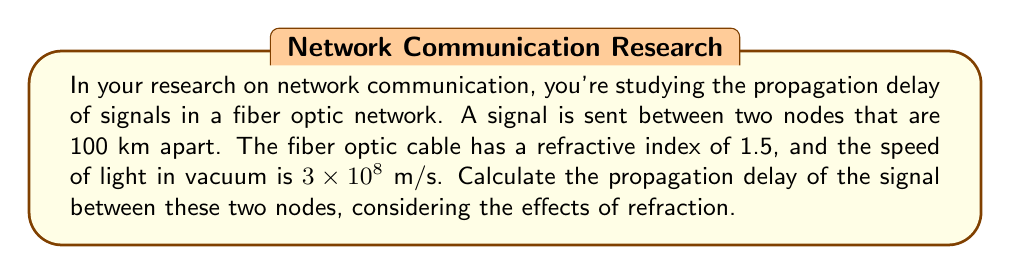Show me your answer to this math problem. To solve this problem, we need to follow these steps:

1. Understand the given information:
   - Distance between nodes: $d = 100$ km = $1 \times 10^5$ m
   - Refractive index of the fiber optic cable: $n = 1.5$
   - Speed of light in vacuum: $c = 3 \times 10^8$ m/s

2. Calculate the speed of light in the fiber optic cable:
   The speed of light in a medium is given by the formula:
   $$v = \frac{c}{n}$$
   Where $v$ is the speed of light in the medium, $c$ is the speed of light in vacuum, and $n$ is the refractive index.

   Substituting the values:
   $$v = \frac{3 \times 10^8}{1.5} = 2 \times 10^8 \text{ m/s}$$

3. Calculate the propagation delay:
   The propagation delay is the time taken for the signal to travel from one node to another. It's given by the formula:
   $$t = \frac{d}{v}$$
   Where $t$ is the propagation delay, $d$ is the distance, and $v$ is the speed of the signal.

   Substituting the values:
   $$t = \frac{1 \times 10^5}{2 \times 10^8} = 0.0005 \text{ seconds}$$

4. Convert the result to milliseconds for better readability:
   $$t = 0.0005 \times 1000 = 0.5 \text{ ms}$$

Therefore, the propagation delay of the signal between the two nodes is 0.5 milliseconds.
Answer: 0.5 ms 